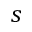<formula> <loc_0><loc_0><loc_500><loc_500>s</formula> 